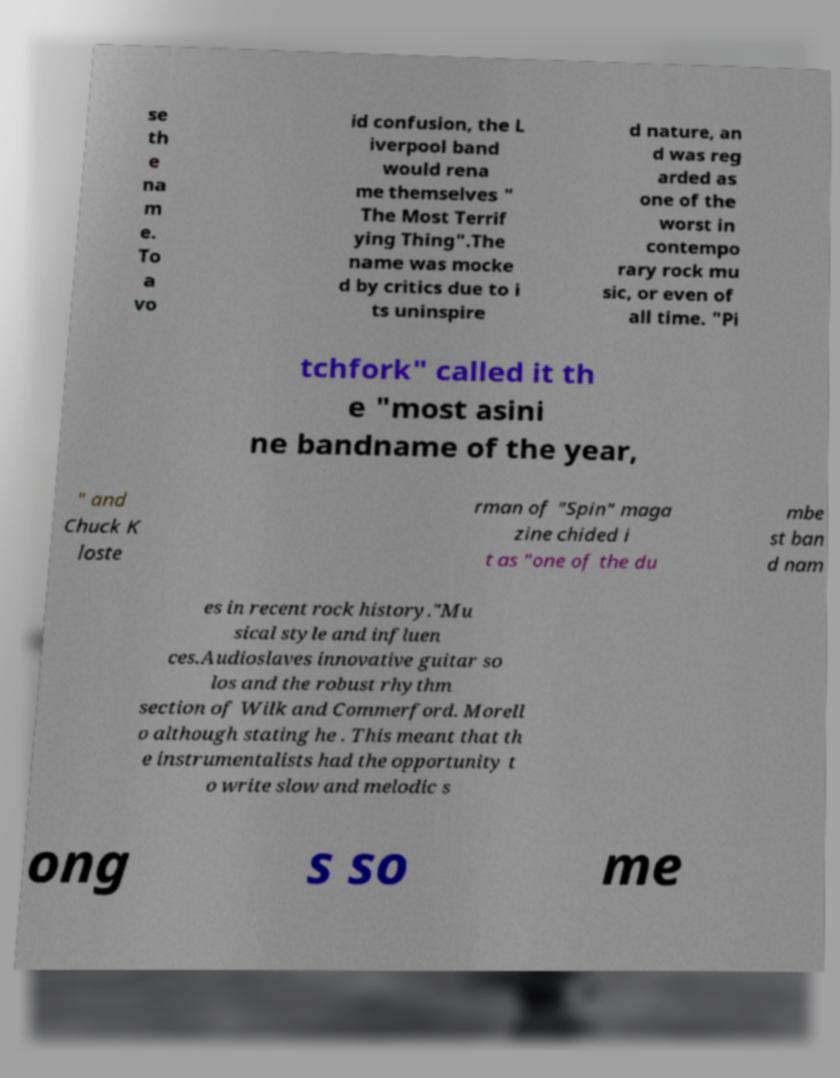There's text embedded in this image that I need extracted. Can you transcribe it verbatim? se th e na m e. To a vo id confusion, the L iverpool band would rena me themselves " The Most Terrif ying Thing".The name was mocke d by critics due to i ts uninspire d nature, an d was reg arded as one of the worst in contempo rary rock mu sic, or even of all time. "Pi tchfork" called it th e "most asini ne bandname of the year, " and Chuck K loste rman of "Spin" maga zine chided i t as "one of the du mbe st ban d nam es in recent rock history."Mu sical style and influen ces.Audioslaves innovative guitar so los and the robust rhythm section of Wilk and Commerford. Morell o although stating he . This meant that th e instrumentalists had the opportunity t o write slow and melodic s ong s so me 